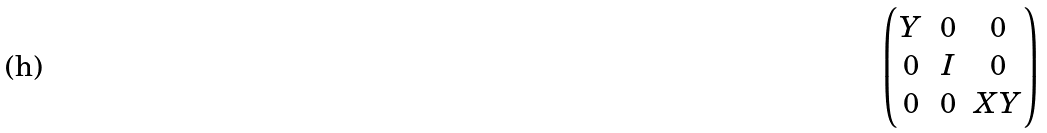<formula> <loc_0><loc_0><loc_500><loc_500>\begin{pmatrix} Y & 0 & 0 \\ 0 & I & 0 \\ 0 & 0 & X Y \end{pmatrix}</formula> 